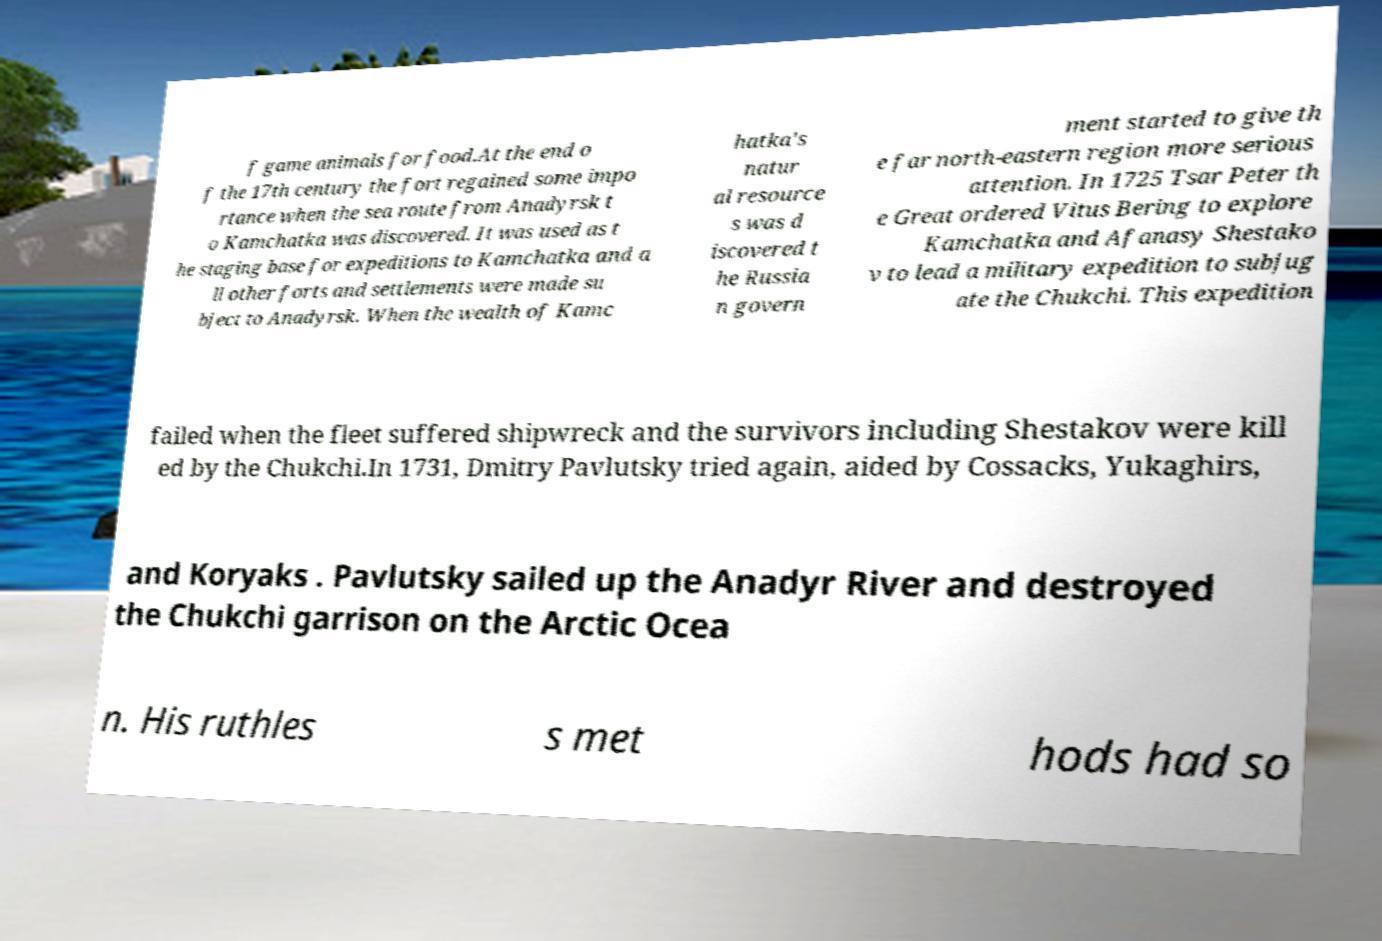For documentation purposes, I need the text within this image transcribed. Could you provide that? f game animals for food.At the end o f the 17th century the fort regained some impo rtance when the sea route from Anadyrsk t o Kamchatka was discovered. It was used as t he staging base for expeditions to Kamchatka and a ll other forts and settlements were made su bject to Anadyrsk. When the wealth of Kamc hatka's natur al resource s was d iscovered t he Russia n govern ment started to give th e far north-eastern region more serious attention. In 1725 Tsar Peter th e Great ordered Vitus Bering to explore Kamchatka and Afanasy Shestako v to lead a military expedition to subjug ate the Chukchi. This expedition failed when the fleet suffered shipwreck and the survivors including Shestakov were kill ed by the Chukchi.In 1731, Dmitry Pavlutsky tried again, aided by Cossacks, Yukaghirs, and Koryaks . Pavlutsky sailed up the Anadyr River and destroyed the Chukchi garrison on the Arctic Ocea n. His ruthles s met hods had so 